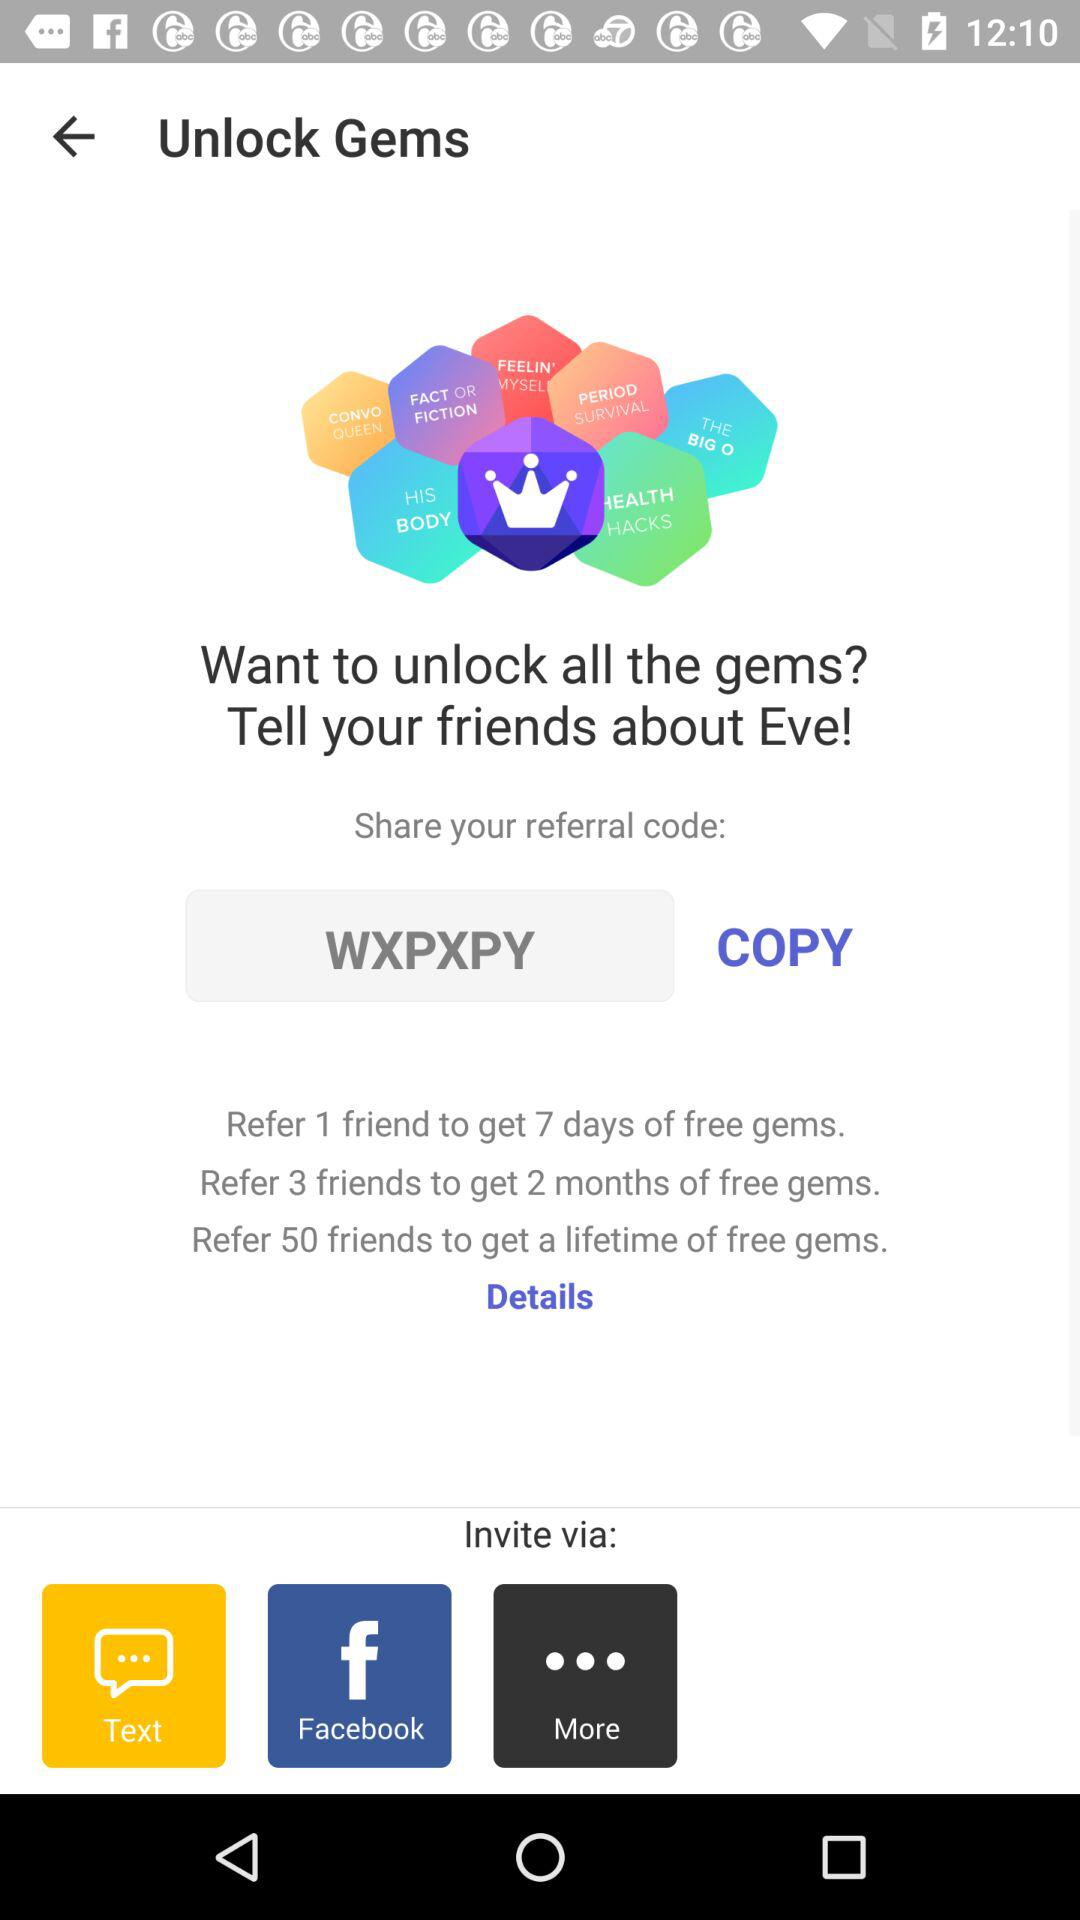How many free gems do we get when we refer 3 friends? You get 2 months of free gems when you refer 3 friends. 